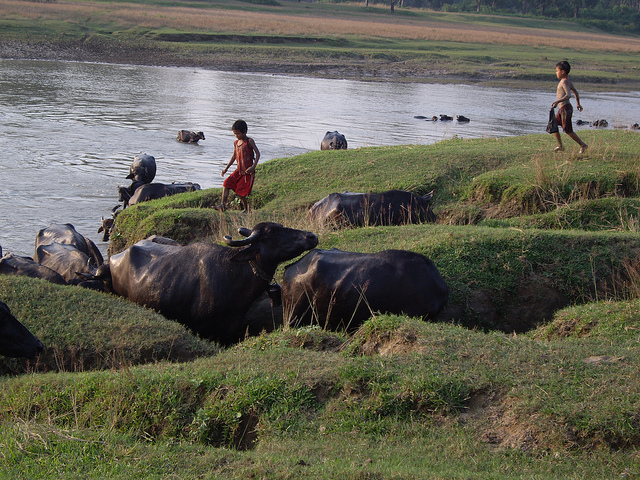<image>Is this in America? It's not clear if this is in America. The opinions vary considerably. Is this in America? I am not sure if this is in America. It can be both in America and not in America. 